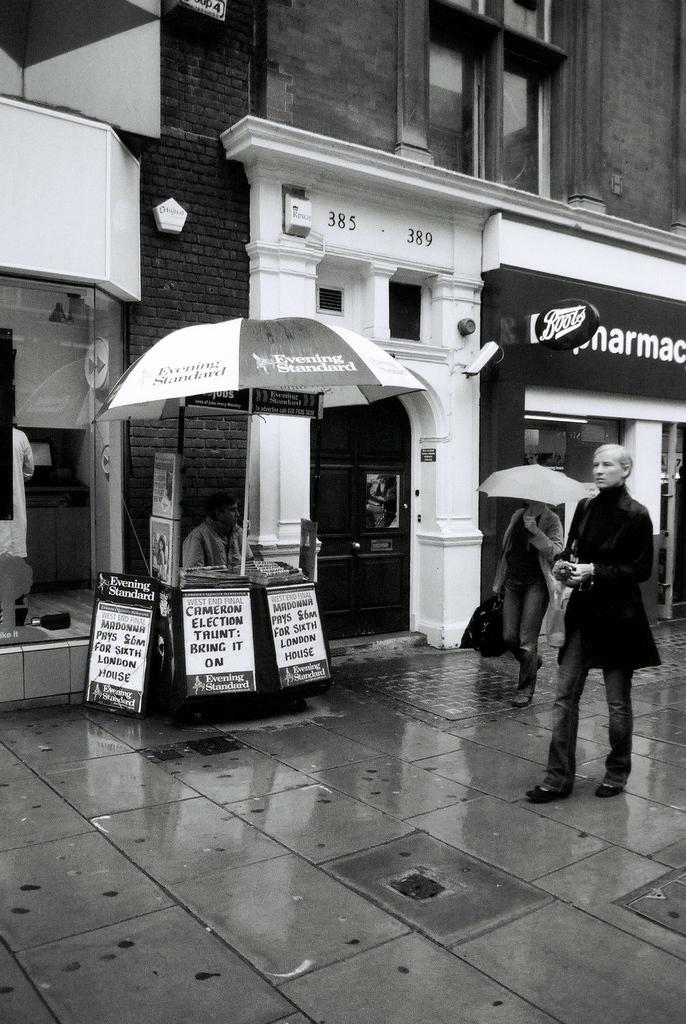What is the color scheme of the image? The image is black and white. Who or what can be seen in the image? There are people in the image. What objects are present in the image that might provide protection from the elements? There are umbrellas in the image. What type of signage is visible in the image? There are boards with text in the image. Can you describe the structure in the image? There is a wall with windows and doors in the image. What is visible beneath the people and objects in the image? The ground is visible in the image. What material is present in the image that might be transparent or reflective? There is some glass in the image. What time of day is it in the image, and what is the farmer doing? The image does not provide information about the time of day or the presence of a farmer. 